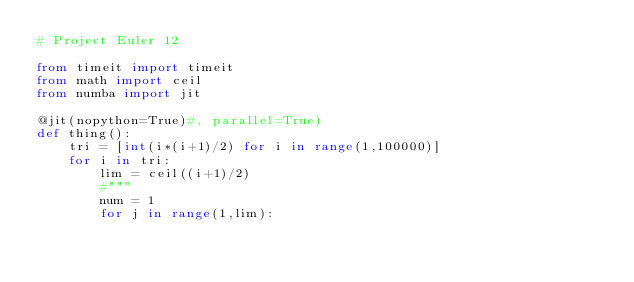Convert code to text. <code><loc_0><loc_0><loc_500><loc_500><_Python_># Project Euler 12

from timeit import timeit
from math import ceil
from numba import jit

@jit(nopython=True)#, parallel=True)
def thing():
    tri = [int(i*(i+1)/2) for i in range(1,100000)]
    for i in tri:
        lim = ceil((i+1)/2)
        #"""
        num = 1
        for j in range(1,lim):</code> 